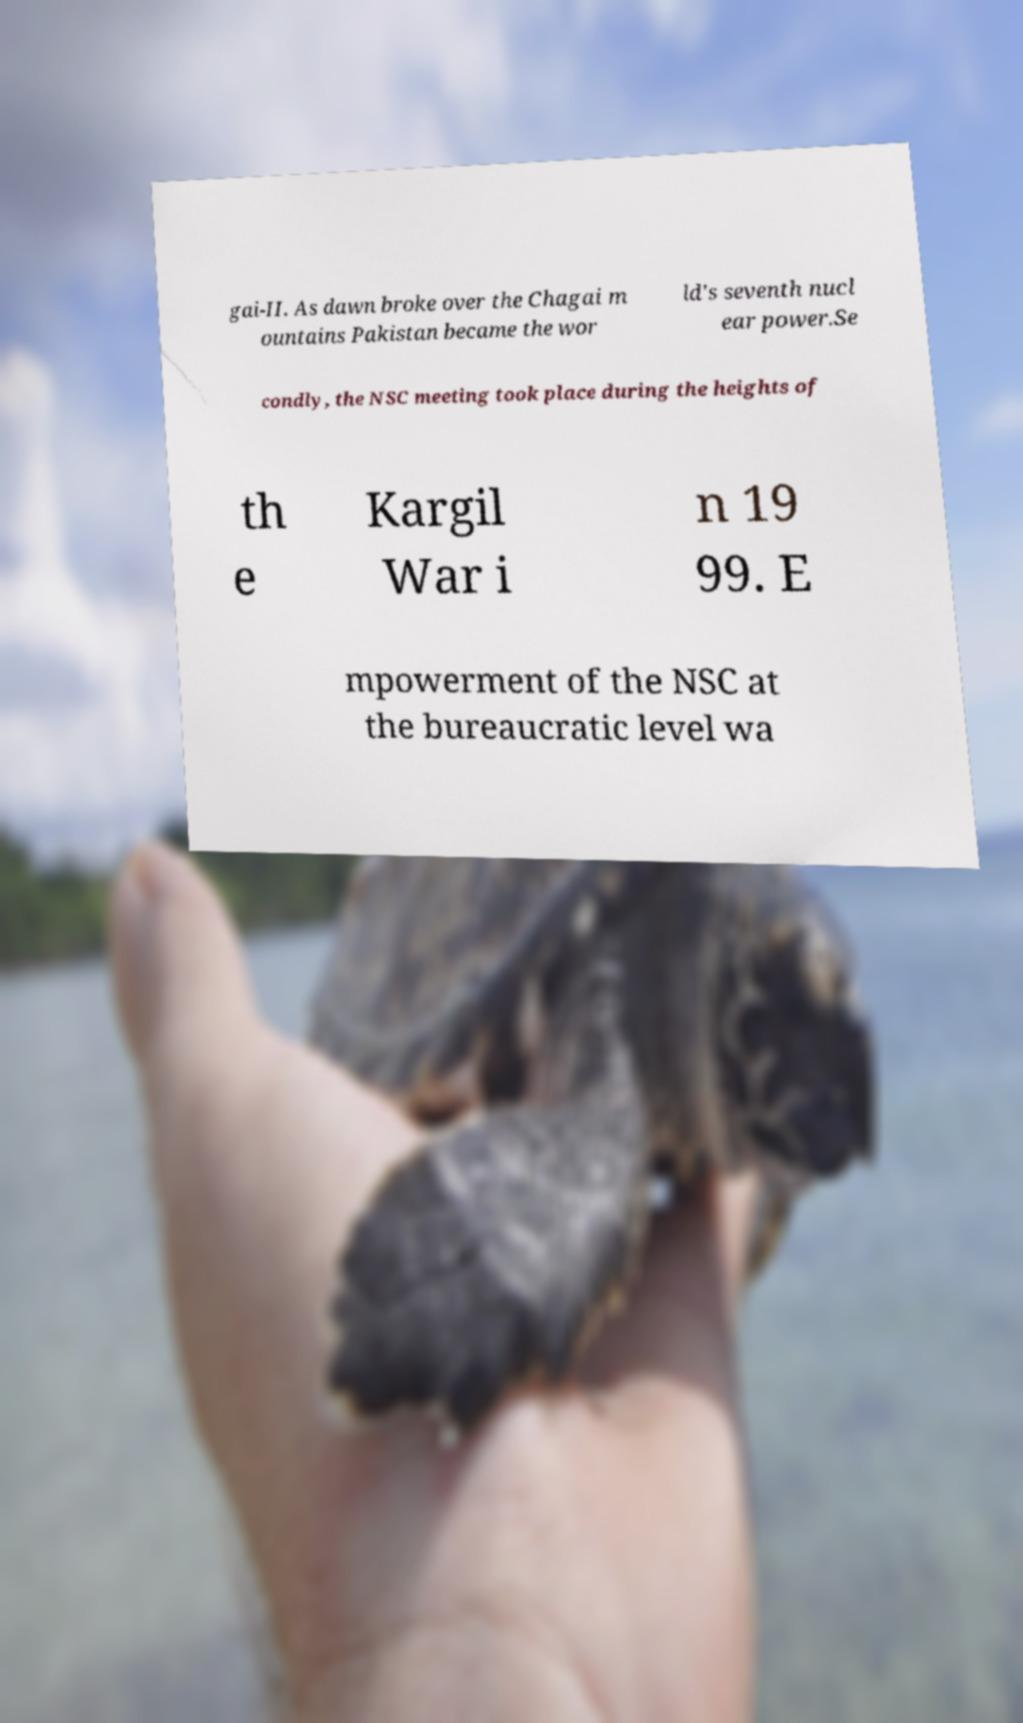What messages or text are displayed in this image? I need them in a readable, typed format. gai-II. As dawn broke over the Chagai m ountains Pakistan became the wor ld's seventh nucl ear power.Se condly, the NSC meeting took place during the heights of th e Kargil War i n 19 99. E mpowerment of the NSC at the bureaucratic level wa 